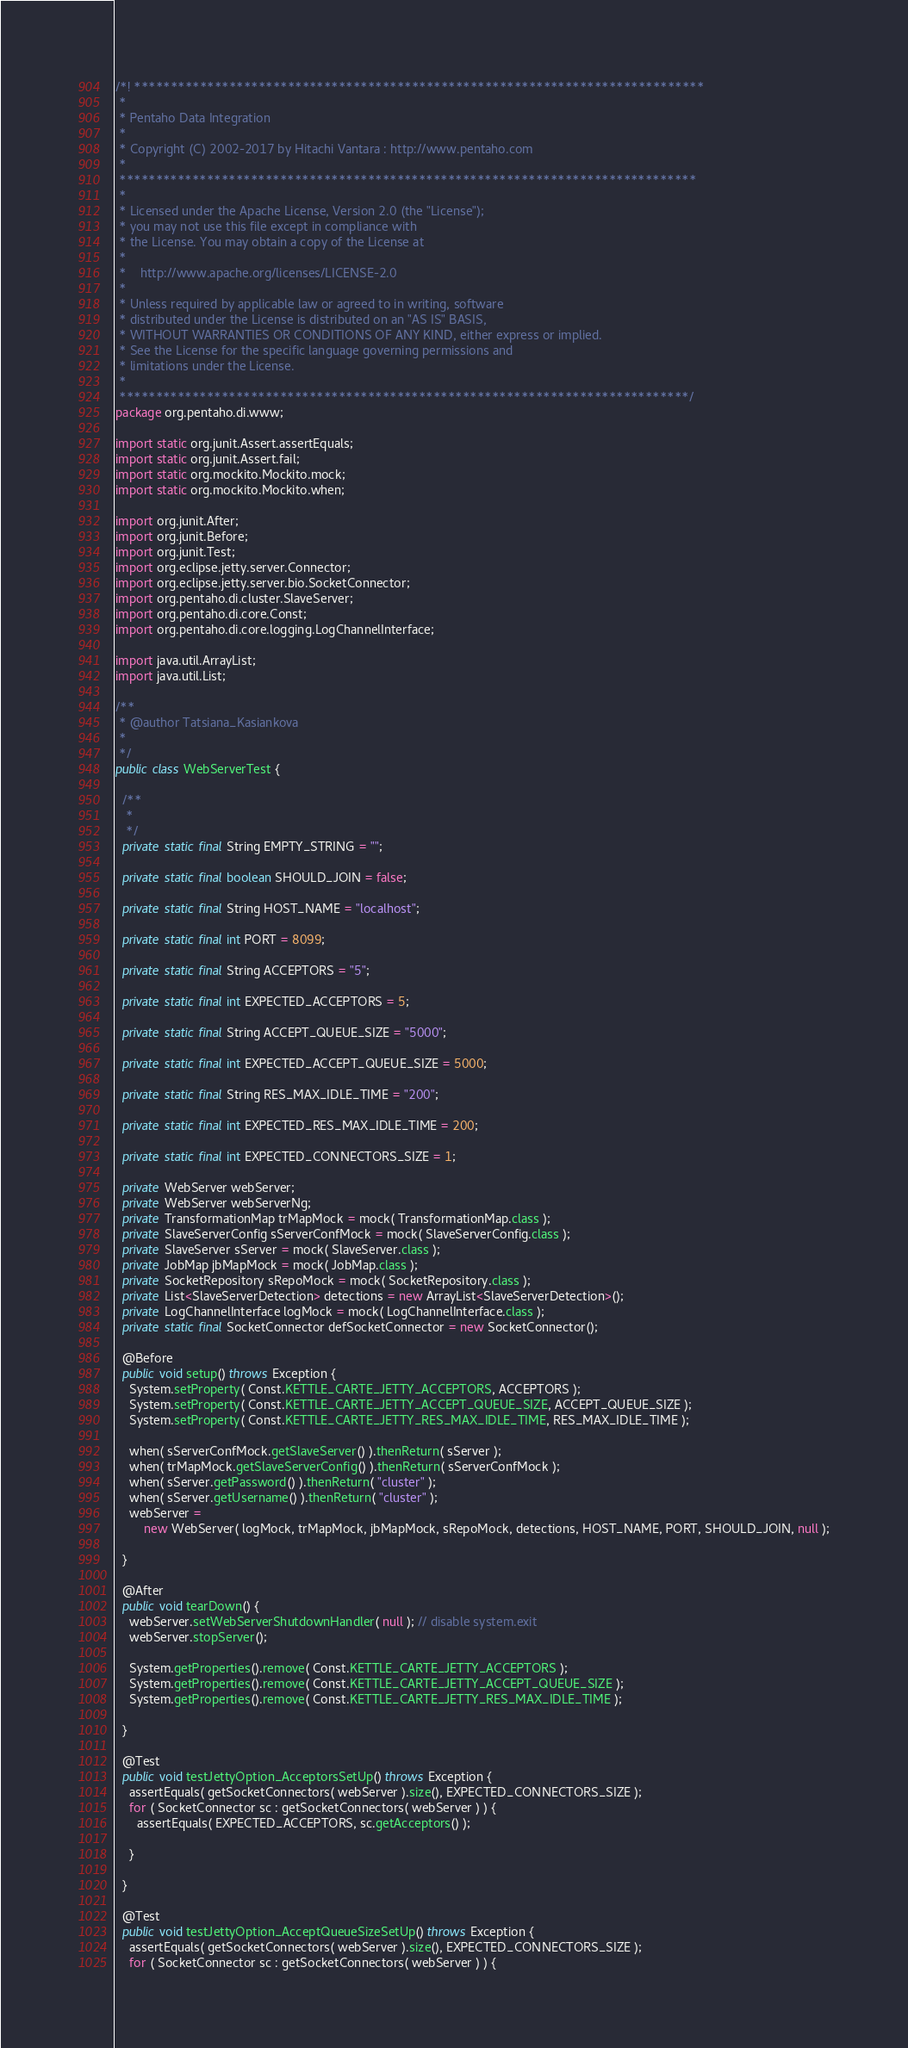Convert code to text. <code><loc_0><loc_0><loc_500><loc_500><_Java_>/*! ******************************************************************************
 *
 * Pentaho Data Integration
 *
 * Copyright (C) 2002-2017 by Hitachi Vantara : http://www.pentaho.com
 *
 *******************************************************************************
 *
 * Licensed under the Apache License, Version 2.0 (the "License");
 * you may not use this file except in compliance with
 * the License. You may obtain a copy of the License at
 *
 *    http://www.apache.org/licenses/LICENSE-2.0
 *
 * Unless required by applicable law or agreed to in writing, software
 * distributed under the License is distributed on an "AS IS" BASIS,
 * WITHOUT WARRANTIES OR CONDITIONS OF ANY KIND, either express or implied.
 * See the License for the specific language governing permissions and
 * limitations under the License.
 *
 ******************************************************************************/
package org.pentaho.di.www;

import static org.junit.Assert.assertEquals;
import static org.junit.Assert.fail;
import static org.mockito.Mockito.mock;
import static org.mockito.Mockito.when;

import org.junit.After;
import org.junit.Before;
import org.junit.Test;
import org.eclipse.jetty.server.Connector;
import org.eclipse.jetty.server.bio.SocketConnector;
import org.pentaho.di.cluster.SlaveServer;
import org.pentaho.di.core.Const;
import org.pentaho.di.core.logging.LogChannelInterface;

import java.util.ArrayList;
import java.util.List;

/**
 * @author Tatsiana_Kasiankova
 * 
 */
public class WebServerTest {

  /**
   * 
   */
  private static final String EMPTY_STRING = "";

  private static final boolean SHOULD_JOIN = false;

  private static final String HOST_NAME = "localhost";

  private static final int PORT = 8099;

  private static final String ACCEPTORS = "5";

  private static final int EXPECTED_ACCEPTORS = 5;

  private static final String ACCEPT_QUEUE_SIZE = "5000";

  private static final int EXPECTED_ACCEPT_QUEUE_SIZE = 5000;

  private static final String RES_MAX_IDLE_TIME = "200";

  private static final int EXPECTED_RES_MAX_IDLE_TIME = 200;

  private static final int EXPECTED_CONNECTORS_SIZE = 1;

  private WebServer webServer;
  private WebServer webServerNg;
  private TransformationMap trMapMock = mock( TransformationMap.class );
  private SlaveServerConfig sServerConfMock = mock( SlaveServerConfig.class );
  private SlaveServer sServer = mock( SlaveServer.class );
  private JobMap jbMapMock = mock( JobMap.class );
  private SocketRepository sRepoMock = mock( SocketRepository.class );
  private List<SlaveServerDetection> detections = new ArrayList<SlaveServerDetection>();
  private LogChannelInterface logMock = mock( LogChannelInterface.class );
  private static final SocketConnector defSocketConnector = new SocketConnector();

  @Before
  public void setup() throws Exception {
    System.setProperty( Const.KETTLE_CARTE_JETTY_ACCEPTORS, ACCEPTORS );
    System.setProperty( Const.KETTLE_CARTE_JETTY_ACCEPT_QUEUE_SIZE, ACCEPT_QUEUE_SIZE );
    System.setProperty( Const.KETTLE_CARTE_JETTY_RES_MAX_IDLE_TIME, RES_MAX_IDLE_TIME );

    when( sServerConfMock.getSlaveServer() ).thenReturn( sServer );
    when( trMapMock.getSlaveServerConfig() ).thenReturn( sServerConfMock );
    when( sServer.getPassword() ).thenReturn( "cluster" );
    when( sServer.getUsername() ).thenReturn( "cluster" );
    webServer =
        new WebServer( logMock, trMapMock, jbMapMock, sRepoMock, detections, HOST_NAME, PORT, SHOULD_JOIN, null );

  }

  @After
  public void tearDown() {
    webServer.setWebServerShutdownHandler( null ); // disable system.exit
    webServer.stopServer();

    System.getProperties().remove( Const.KETTLE_CARTE_JETTY_ACCEPTORS );
    System.getProperties().remove( Const.KETTLE_CARTE_JETTY_ACCEPT_QUEUE_SIZE );
    System.getProperties().remove( Const.KETTLE_CARTE_JETTY_RES_MAX_IDLE_TIME );

  }

  @Test
  public void testJettyOption_AcceptorsSetUp() throws Exception {
    assertEquals( getSocketConnectors( webServer ).size(), EXPECTED_CONNECTORS_SIZE );
    for ( SocketConnector sc : getSocketConnectors( webServer ) ) {
      assertEquals( EXPECTED_ACCEPTORS, sc.getAcceptors() );

    }

  }

  @Test
  public void testJettyOption_AcceptQueueSizeSetUp() throws Exception {
    assertEquals( getSocketConnectors( webServer ).size(), EXPECTED_CONNECTORS_SIZE );
    for ( SocketConnector sc : getSocketConnectors( webServer ) ) {</code> 